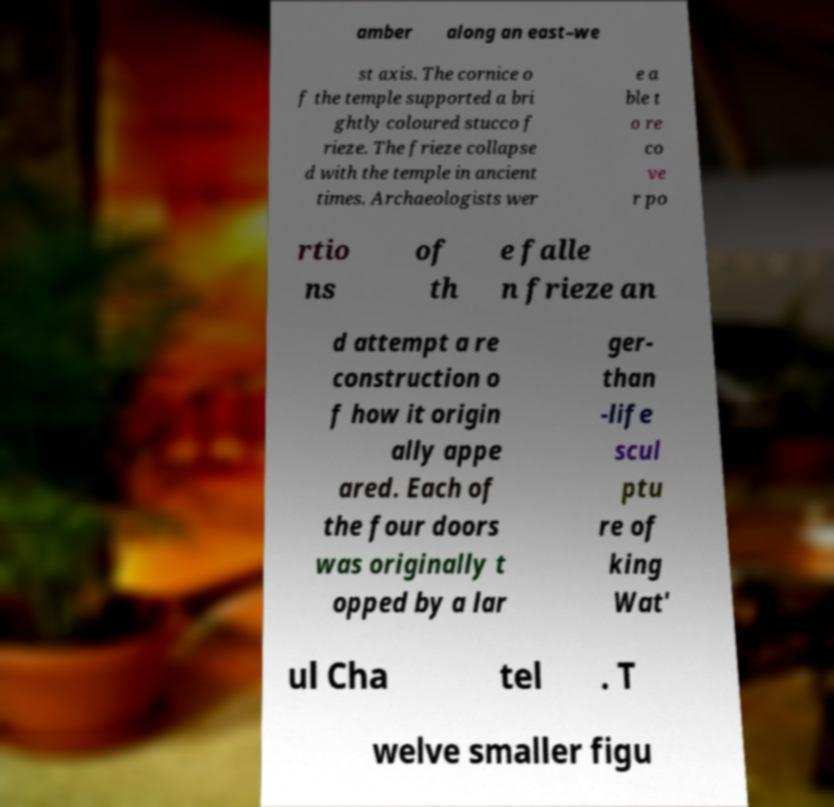For documentation purposes, I need the text within this image transcribed. Could you provide that? amber along an east–we st axis. The cornice o f the temple supported a bri ghtly coloured stucco f rieze. The frieze collapse d with the temple in ancient times. Archaeologists wer e a ble t o re co ve r po rtio ns of th e falle n frieze an d attempt a re construction o f how it origin ally appe ared. Each of the four doors was originally t opped by a lar ger- than -life scul ptu re of king Wat' ul Cha tel . T welve smaller figu 